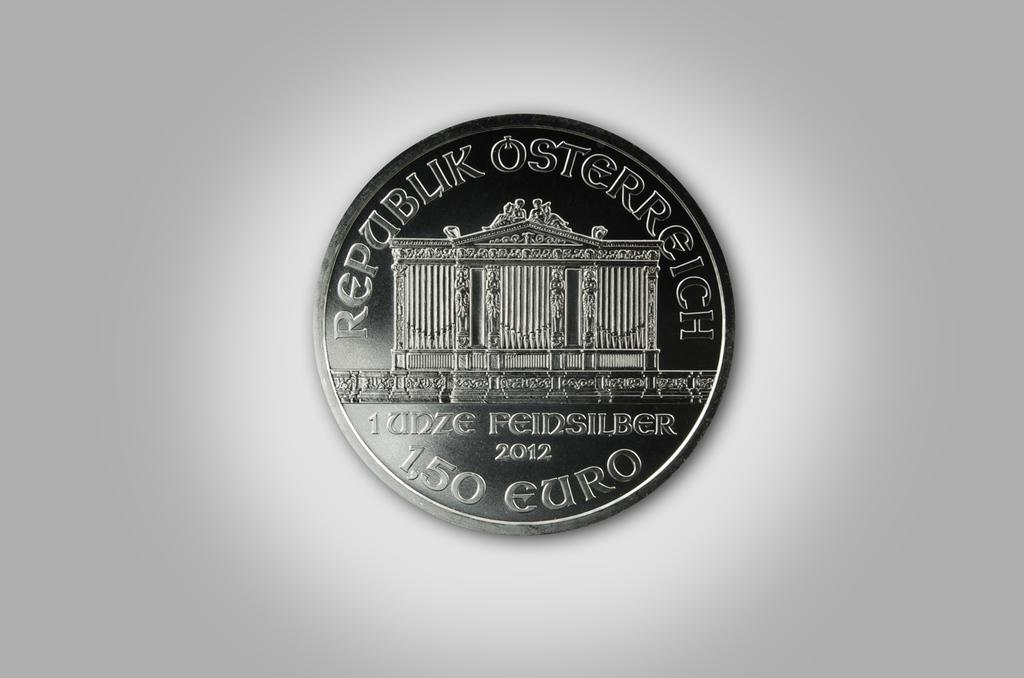What object can be seen in the image that has monetary value? There is a coin in the image that has monetary value. What is written or engraved on the coin? The coin has text on it. What type of structure is visible in the image? There is a structure of a building in the image. What color is the background of the image? The background of the image is white. What type of yarn is being used to create the bottle in the image? There is no yarn or bottle present in the image. On which side of the image is the side of the building visible? The image does not show a specific side of the building; it only shows a structure of a building. 